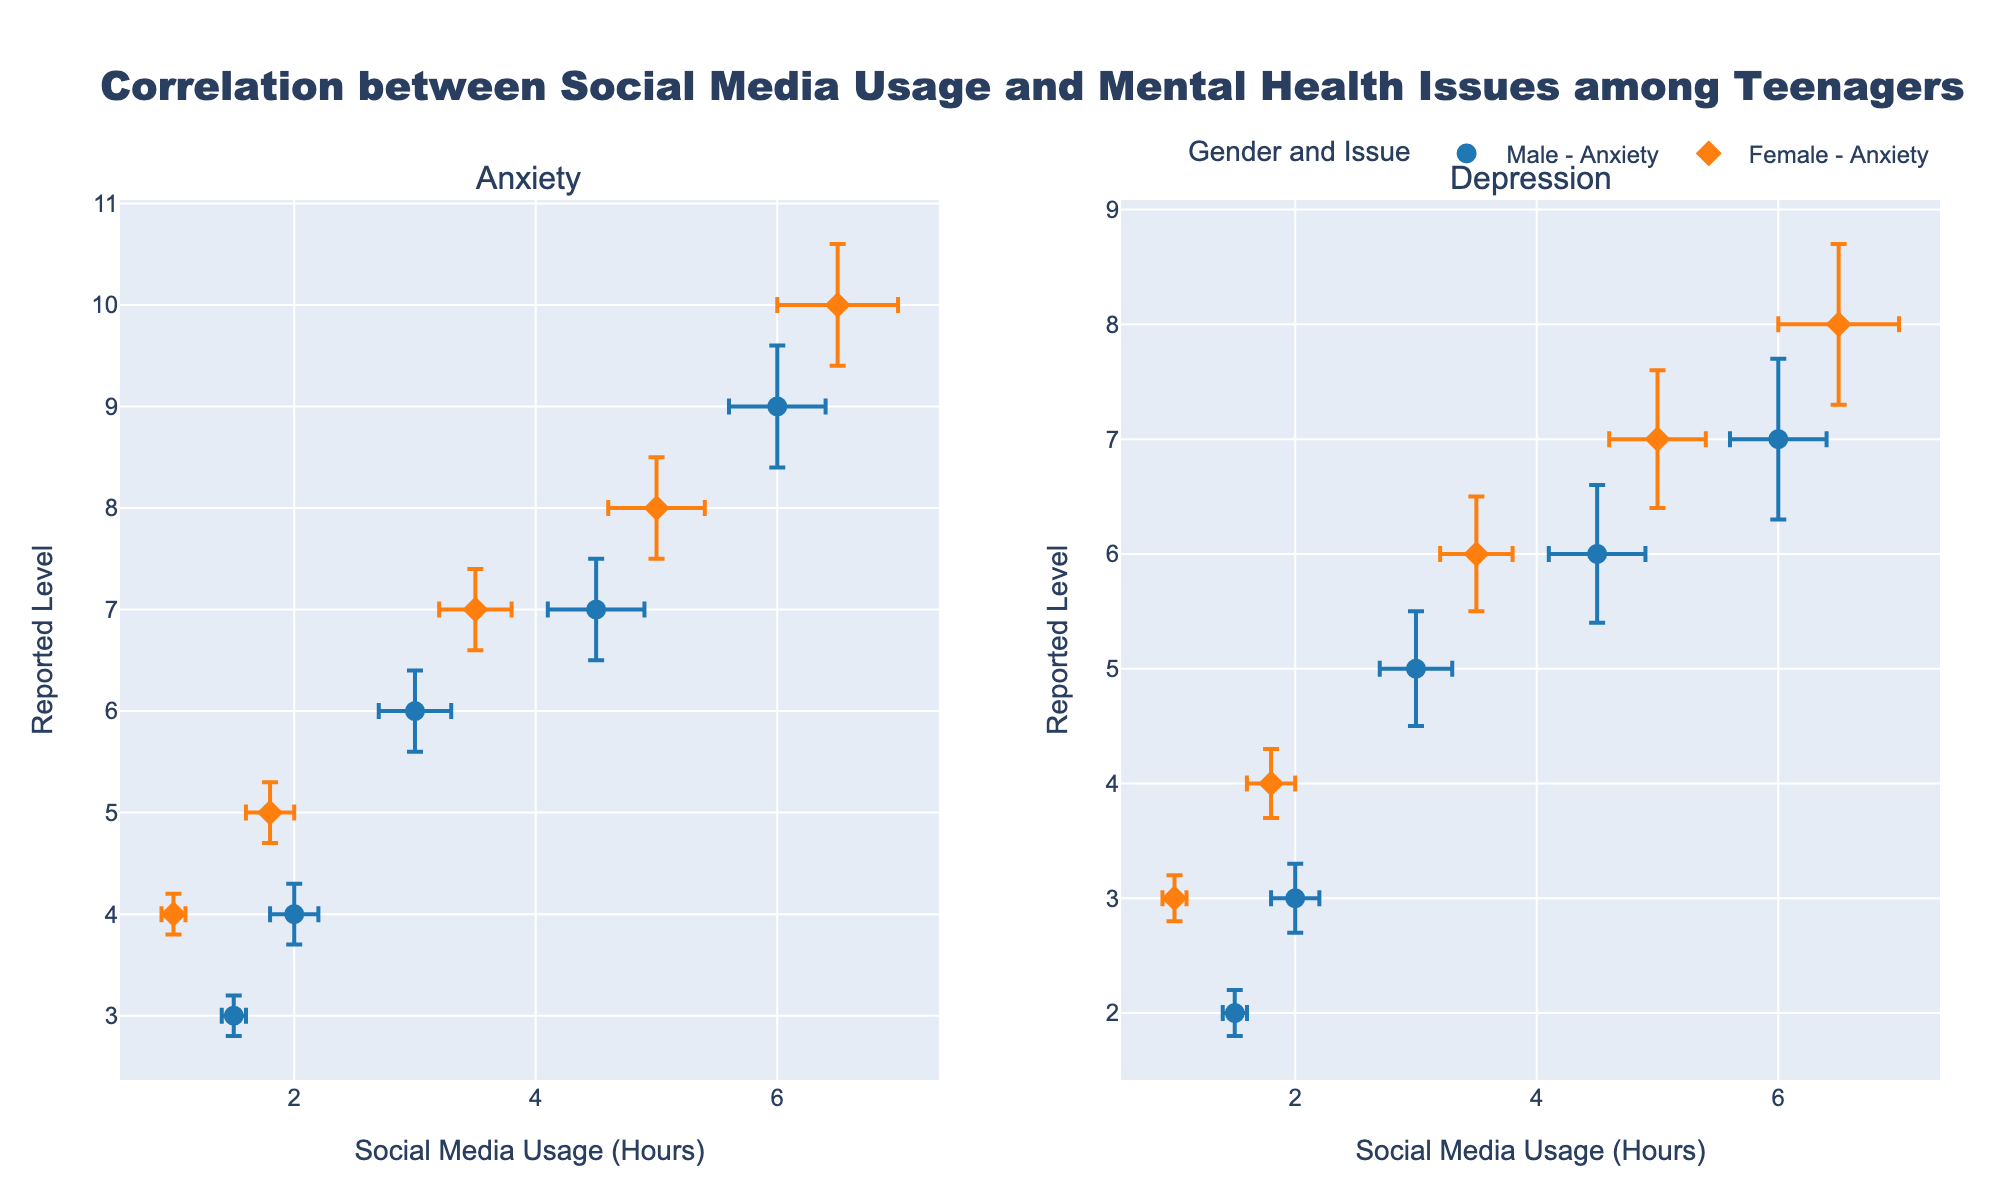Which gender shows a higher average level of reported anxiety? To determine the average anxiety level for each gender, examine the y-values for the "Anxiety" subplot. Males have data points at 3, 4, 6, 7, and 9, averaging (3+4+6+7+9)/5 = 5.8. Females have data points at 4, 5, 7, 8, and 10, averaging (4+5+7+8+10)/5 = 6.8. Thus, females show a higher average level of reported anxiety.
Answer: Females Which subgroup has the smallest error in social media usage hours? To answer, look at the error bars along the x-axis. Males have errors of 0.1, 0.2, 0.3, 0.4, 0.4, and females have errors of 0.1, 0.2, 0.3, 0.4, 0.5. The smallest error in social media usage (0.1) appears in both Male and Female subgroups for their respective lowest social media usage hours.
Answer: Both Is there a positive correlation between social media usage and reported depression levels? Determine the correlation by observing the scatter plot for depression. For both genders, as social media usage hours increase, the reported depression levels also increase, indicating a positive correlation.
Answer: Yes Do males or females exhibit a wider range of social media usage hours? Review the x-axis range for both subgroups. Male social media usage ranges from 1.5 to 6 hours, while female usage ranges from 1 to 6.5 hours. Thus, females exhibit a wider range.
Answer: Females What's the difference between the highest and lowest reported anxiety levels for females? Look at the "Anxiety" subplot for females. The highest anxiety level is 10, and the lowest is 4. The difference is 10 - 4 = 6.
Answer: 6 Comparing males and females, who has the higher highest reported depression level? Check the maximum y-values in the "Depression" subplot. For males, the highest level is 7; for females, it is 8. Thus, females have the higher highest reported depression level.
Answer: Females How does the error in reported depression levels change with social media usage for females? For females in the "Depression" subplot, check the y-error bars relative to x-values. Errors for females (0.2, 0.3, 0.4, 0.5, 0.7) generally increase as social media usage increases.
Answer: Increases 